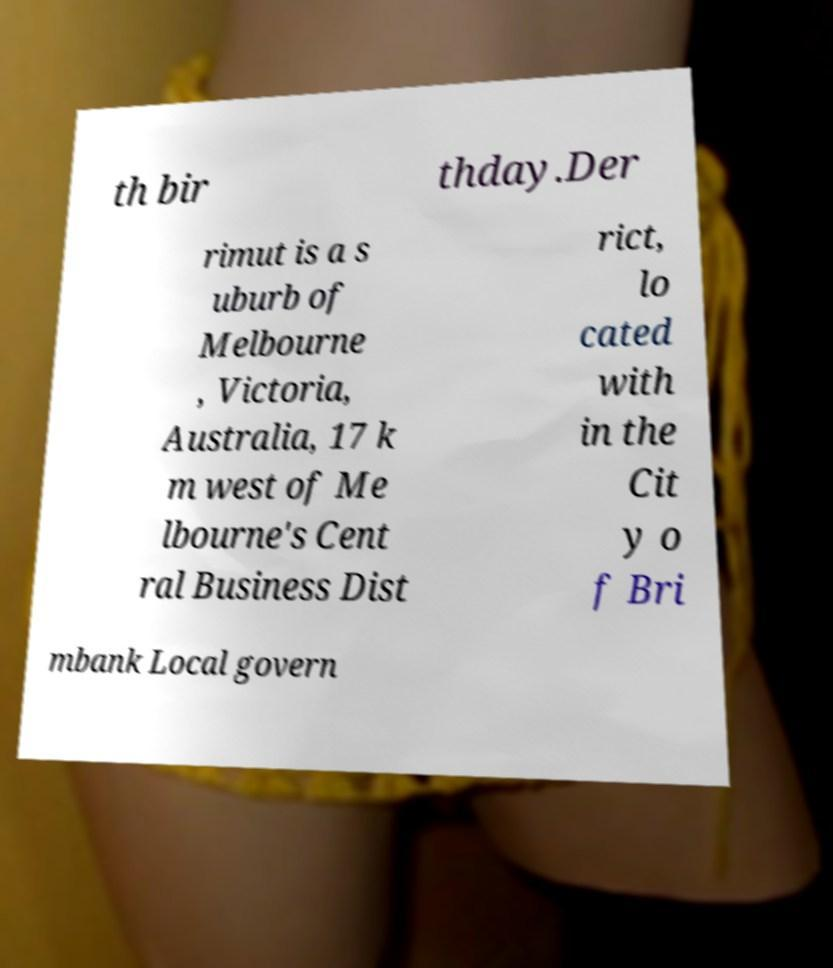Please read and relay the text visible in this image. What does it say? th bir thday.Der rimut is a s uburb of Melbourne , Victoria, Australia, 17 k m west of Me lbourne's Cent ral Business Dist rict, lo cated with in the Cit y o f Bri mbank Local govern 